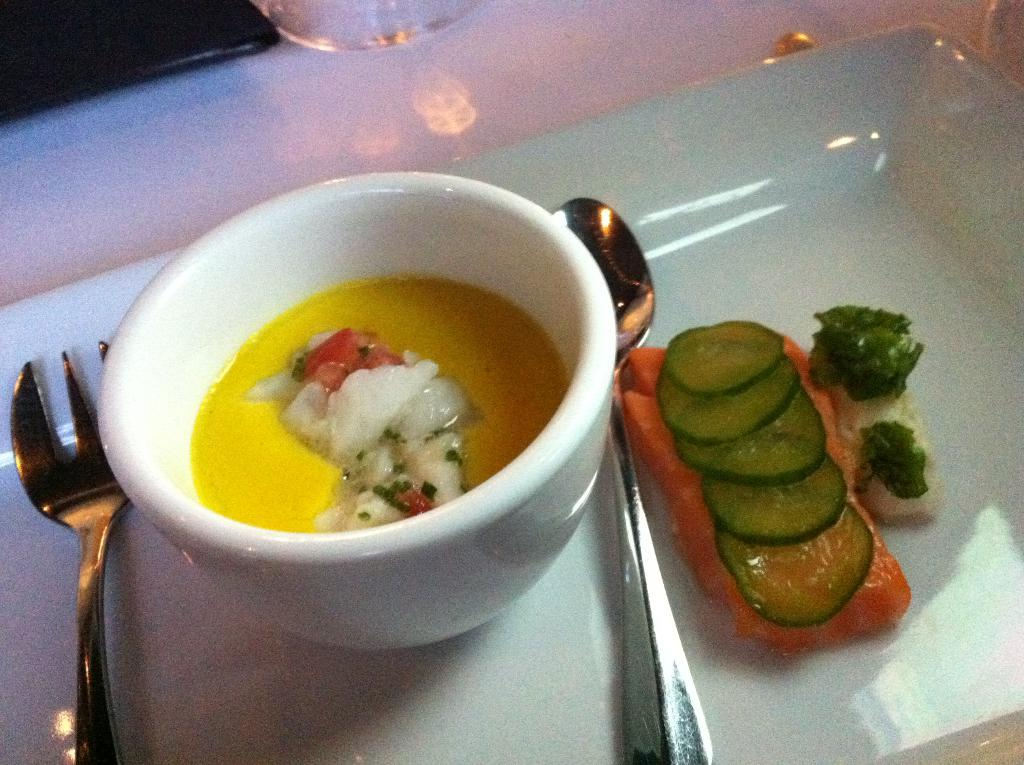What is in the bowl that is visible in the image? There is soup in a bowl in the image. What utensils can be seen in the image? There is cutlery visible in the image. What is on the serving plate in the image? The serving plate contains meat topped with cucumber. Can you hear a whistle in the image? There is no whistle present in the image; it is a still image and does not contain any sounds. 